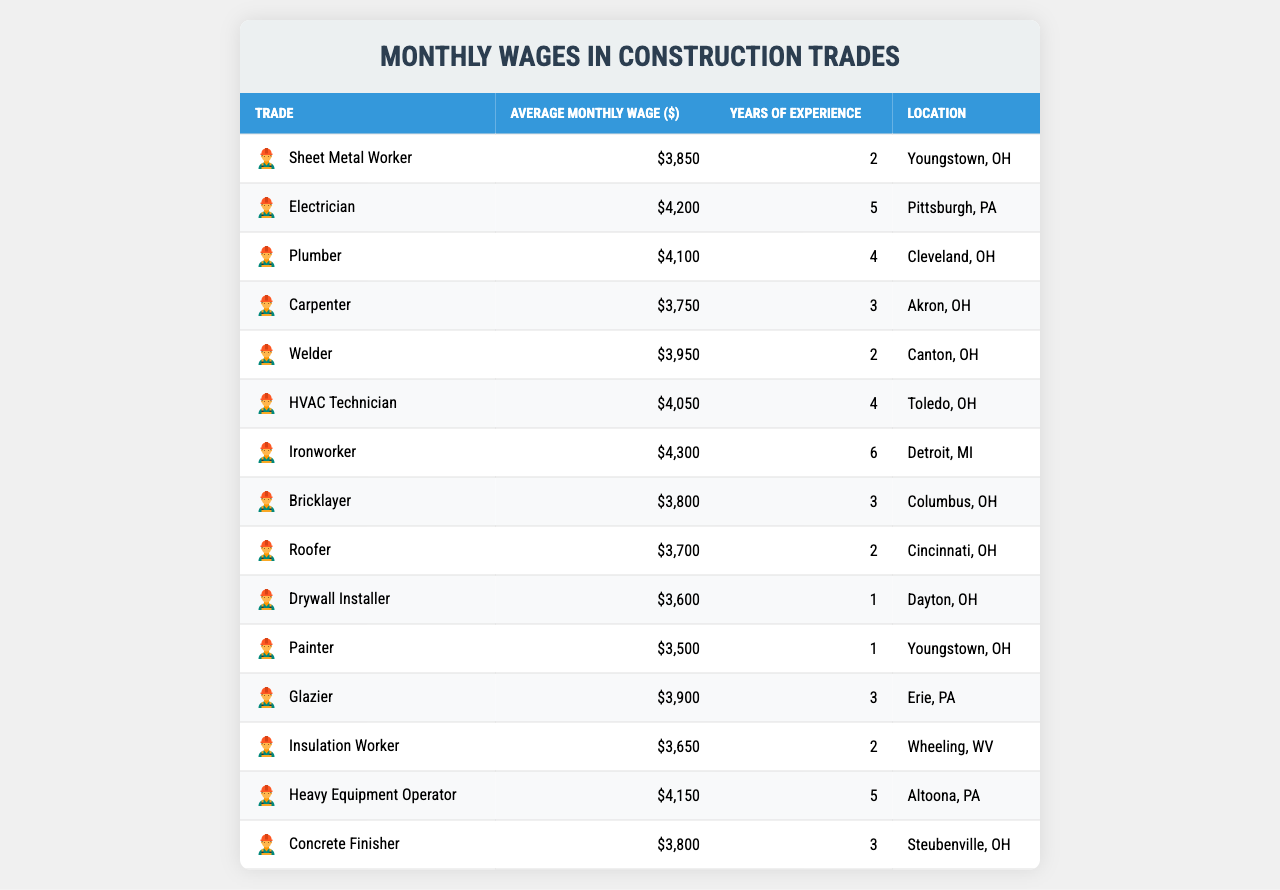What is the average monthly wage for a Sheet Metal Worker? According to the table, the average monthly wage for a Sheet Metal Worker is listed in the second column under "Average Monthly Wage ($)", which shows $3850.
Answer: 3850 Which trade has the highest average monthly wage? The trade with the highest average monthly wage can be identified by looking for the maximum value in the second column. The Ironworker has an average wage of $4300, which is the highest.
Answer: Ironworker How many years of experience does a Plumber typically have? The number of years of experience for a Plumber is shown in the third column of the table, which indicates 4 years.
Answer: 4 Is the average monthly wage for a Roofer higher than a Bricklayer? To determine if the Roofer's wage is higher than that of a Bricklayer, we compare the values in the second column: Roofer is $3700 and Bricklayer is $3800. Since $3700 is not greater than $3800, the statement is false.
Answer: No What is the difference in average monthly wages between Electricians and HVAC Technicians? The average wage for Electricians is $4200 and for HVAC Technicians, it is $4050. The difference is calculated as $4200 - $4050 = $150.
Answer: 150 Which trade with less than 4 years of experience has the lowest wage? We find the trades with less than 4 years of experience (Drywall Installer, Painter, Roofer, Sheet Metal Worker, and Welder). Among those, the Drywall Installer has the lowest wage of $3600.
Answer: Drywall Installer How does the average monthly wage of a Heavy Equipment Operator compare to that of an Ironworker? A Heavy Equipment Operator earns $4150, while an Ironworker earns $4300. Comparing these, Ironworker's wage is higher by $150 ($4300 - $4150 = $150).
Answer: Lower Which trade has the highest wage per year of experience? For each trade, we calculate the wage per year of experience (Average Monthly Wage divided by Years of Experience). The highest is the Ironworker with $4300 / 6 years = $716.67. After calculations for each trade, Ironworker has the highest rate.
Answer: Ironworker How many trades have an average monthly wage above $4000? By examining the second column for wages above $4000, we find Electrician ($4200), Plumber ($4100), HVAC Technician ($4050), and Ironworker ($4300), totaling 4 trades.
Answer: 4 Is the Painter earning more than the average wage of all trades listed? The average wage can be calculated as follows: sum all wages and divide by the number of trades (3850 + 4200 + 4100 + 3750 + 3950 + 4050 + 4300 + 3800 + 3700 + 3600 + 3500 + 3900 + 3650 + 4150 + 3800 = 58,800, divided by 15 trades equals $3920). The Painter's wage of $3500 is below this average.
Answer: No 